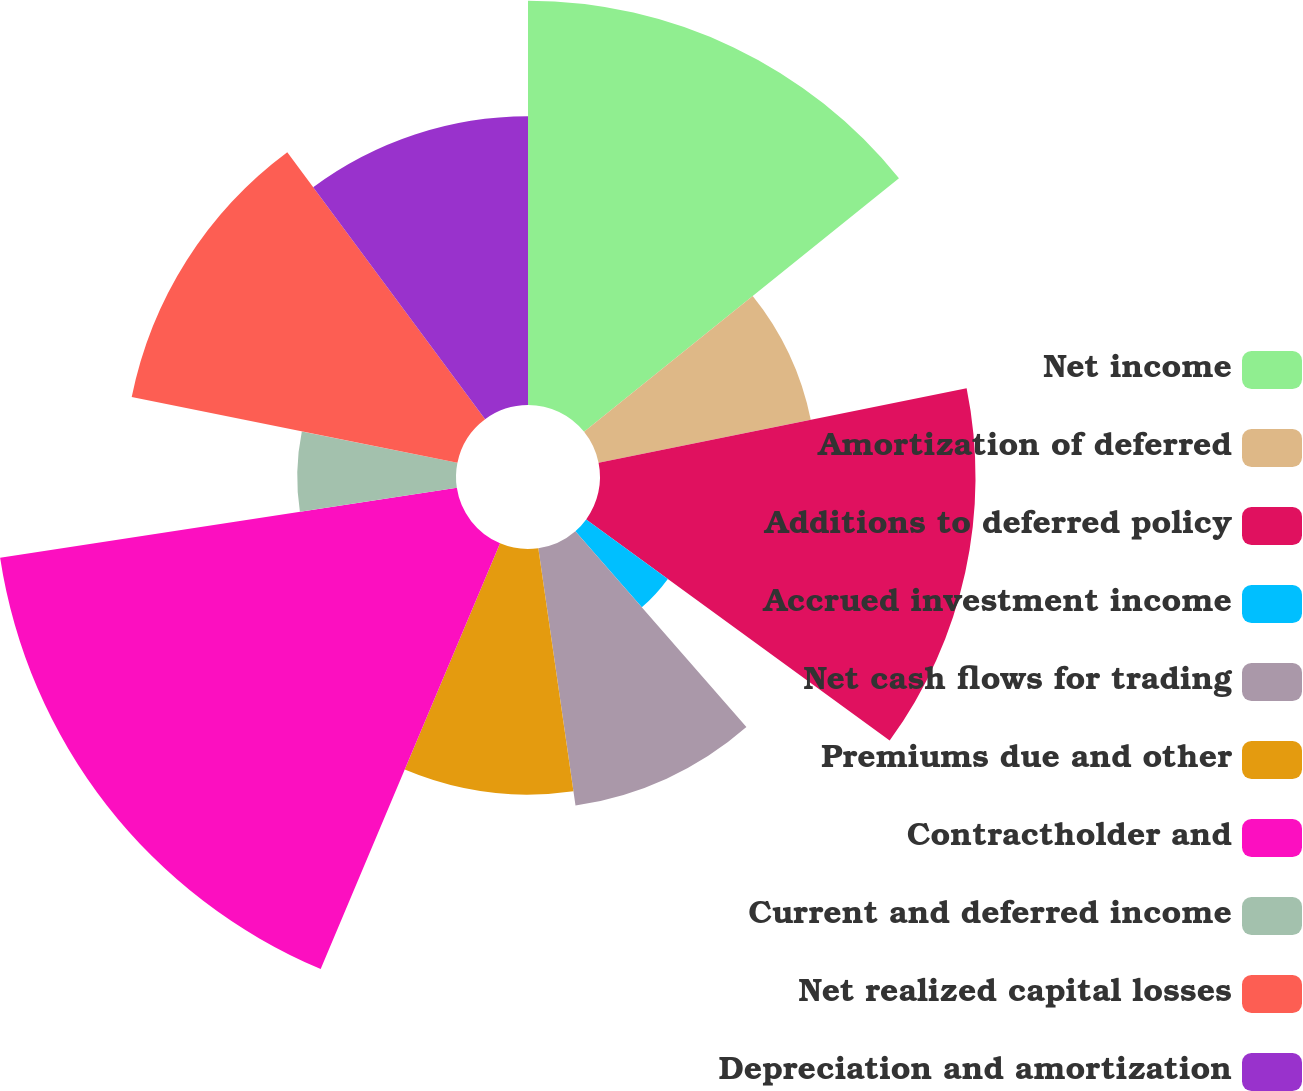Convert chart. <chart><loc_0><loc_0><loc_500><loc_500><pie_chart><fcel>Net income<fcel>Amortization of deferred<fcel>Additions to deferred policy<fcel>Accrued investment income<fcel>Net cash flows for trading<fcel>Premiums due and other<fcel>Contractholder and<fcel>Current and deferred income<fcel>Net realized capital losses<fcel>Depreciation and amortization<nl><fcel>14.21%<fcel>7.61%<fcel>13.2%<fcel>3.55%<fcel>9.14%<fcel>8.63%<fcel>16.24%<fcel>5.58%<fcel>11.68%<fcel>10.15%<nl></chart> 